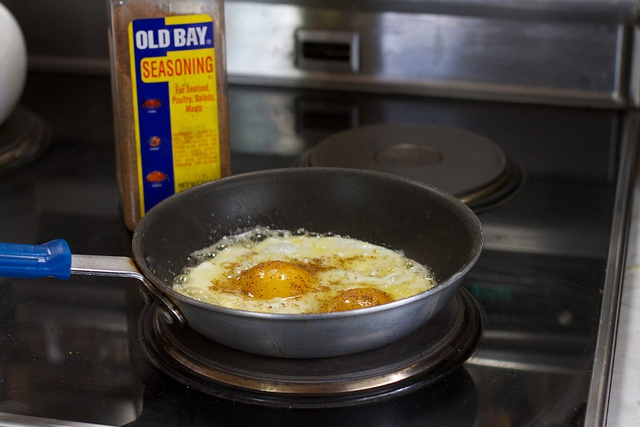Describe the objects in this image and their specific colors. I can see oven in black, gray, navy, and darkgray tones and bottle in black, navy, gold, maroon, and olive tones in this image. 